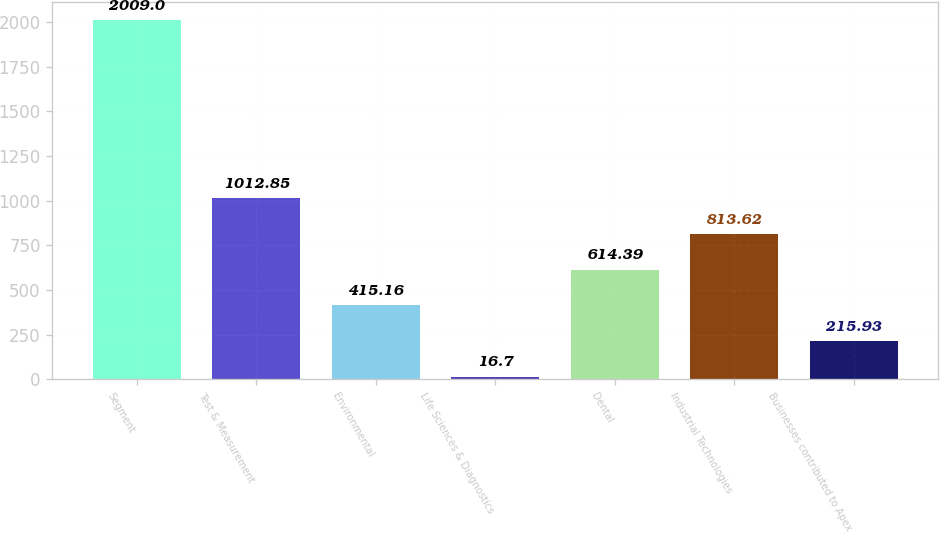<chart> <loc_0><loc_0><loc_500><loc_500><bar_chart><fcel>Segment<fcel>Test & Measurement<fcel>Environmental<fcel>Life Sciences & Diagnostics<fcel>Dental<fcel>Industrial Technologies<fcel>Businesses contributed to Apex<nl><fcel>2009<fcel>1012.85<fcel>415.16<fcel>16.7<fcel>614.39<fcel>813.62<fcel>215.93<nl></chart> 